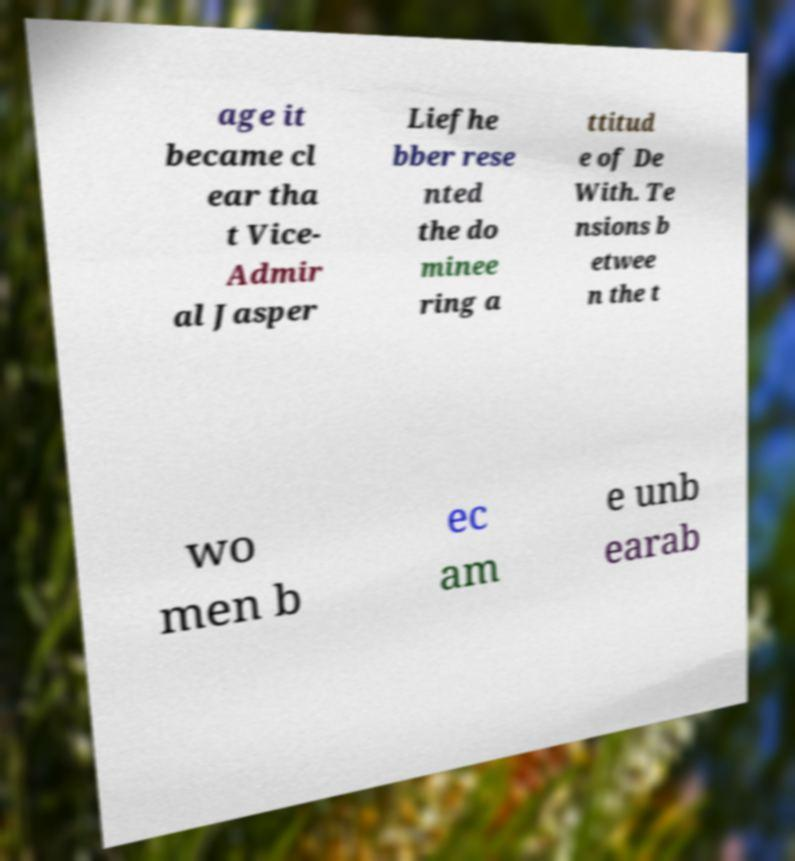For documentation purposes, I need the text within this image transcribed. Could you provide that? age it became cl ear tha t Vice- Admir al Jasper Liefhe bber rese nted the do minee ring a ttitud e of De With. Te nsions b etwee n the t wo men b ec am e unb earab 